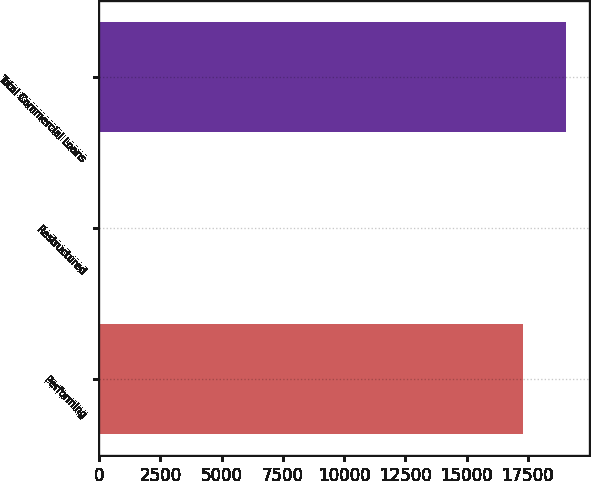<chart> <loc_0><loc_0><loc_500><loc_500><bar_chart><fcel>Performing<fcel>Restructured<fcel>Total Commercial Loans<nl><fcel>17309<fcel>7<fcel>19045.2<nl></chart> 